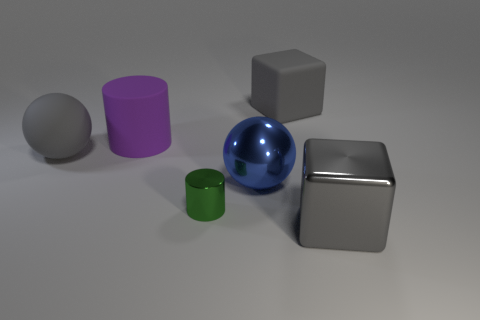Add 1 gray rubber spheres. How many objects exist? 7 Subtract 1 cylinders. How many cylinders are left? 1 Subtract all purple cylinders. How many cylinders are left? 1 Subtract all blue cylinders. How many purple balls are left? 0 Subtract all spheres. How many objects are left? 4 Subtract all gray balls. Subtract all red cubes. How many balls are left? 1 Subtract all tiny yellow rubber cylinders. Subtract all small green metal things. How many objects are left? 5 Add 2 large gray metallic cubes. How many large gray metallic cubes are left? 3 Add 1 big metal balls. How many big metal balls exist? 2 Subtract 0 yellow cylinders. How many objects are left? 6 